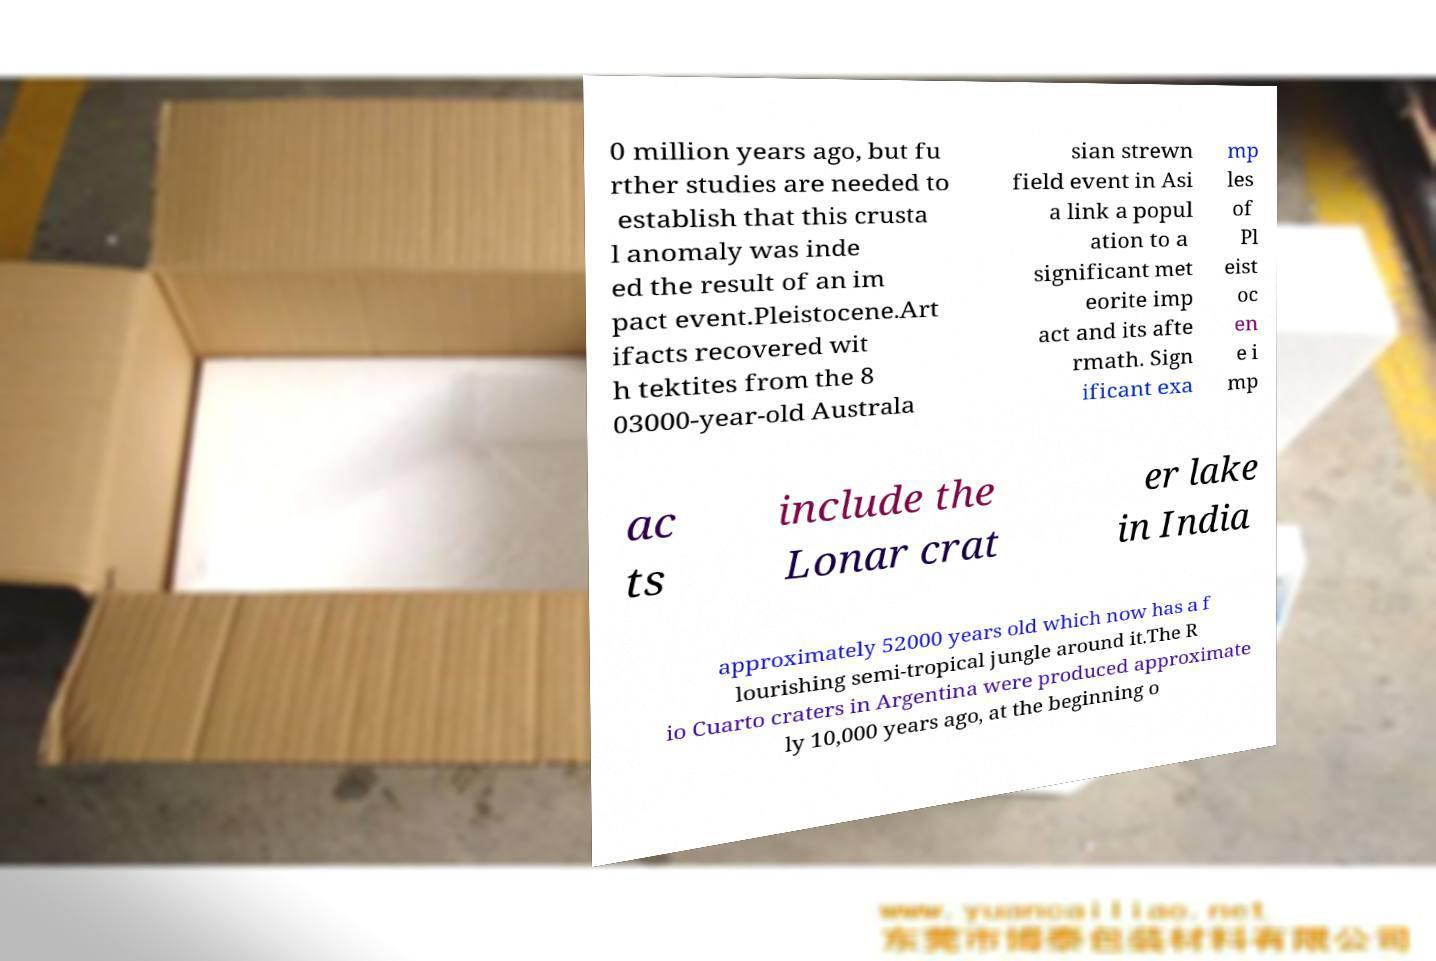For documentation purposes, I need the text within this image transcribed. Could you provide that? 0 million years ago, but fu rther studies are needed to establish that this crusta l anomaly was inde ed the result of an im pact event.Pleistocene.Art ifacts recovered wit h tektites from the 8 03000-year-old Australa sian strewn field event in Asi a link a popul ation to a significant met eorite imp act and its afte rmath. Sign ificant exa mp les of Pl eist oc en e i mp ac ts include the Lonar crat er lake in India approximately 52000 years old which now has a f lourishing semi-tropical jungle around it.The R io Cuarto craters in Argentina were produced approximate ly 10,000 years ago, at the beginning o 